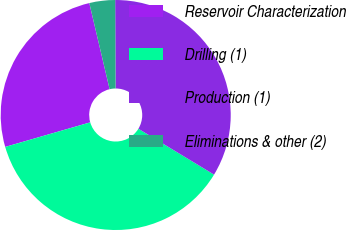Convert chart to OTSL. <chart><loc_0><loc_0><loc_500><loc_500><pie_chart><fcel>Reservoir Characterization<fcel>Drilling (1)<fcel>Production (1)<fcel>Eliminations & other (2)<nl><fcel>25.79%<fcel>36.85%<fcel>33.75%<fcel>3.61%<nl></chart> 